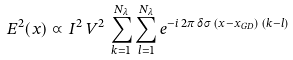<formula> <loc_0><loc_0><loc_500><loc_500>E ^ { 2 } ( x ) \varpropto I ^ { 2 } \, V ^ { 2 } \, \sum _ { k = 1 } ^ { N _ { \lambda } } \sum _ { l = 1 } ^ { N _ { \lambda } } e ^ { - i \, 2 \pi \, \delta \sigma \, ( x - x _ { G D } ) \, ( k - l ) }</formula> 